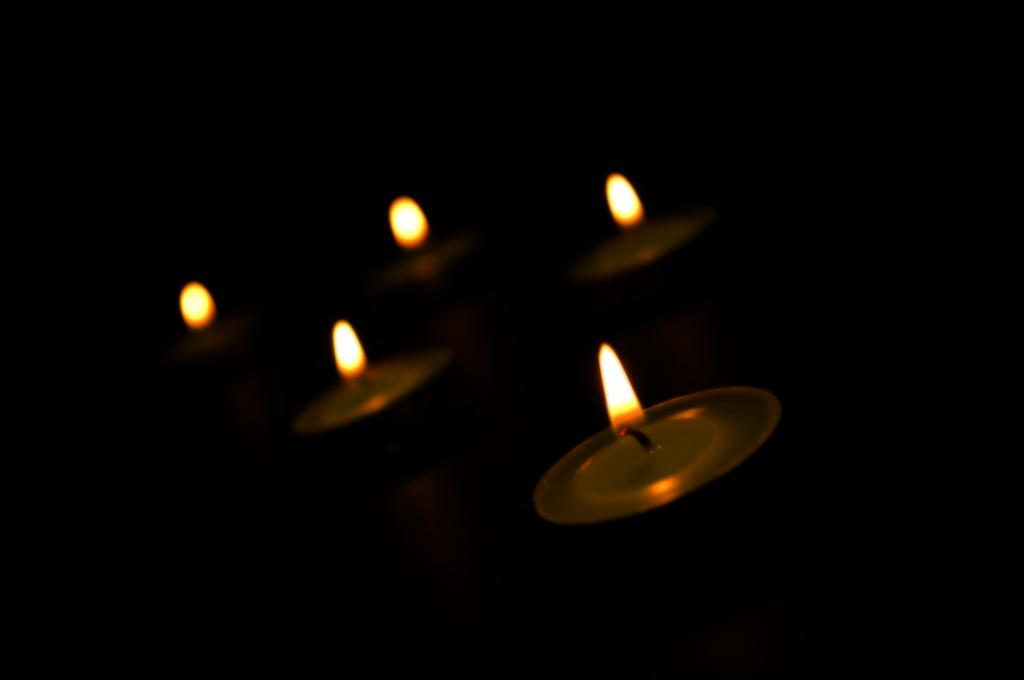What type of objects are in the image? There are small candles in the image. How are the small candles arranged or placed? The small candles are placed in small metal plates. Can you hear the candles laughing in the image? Candles do not have the ability to laugh, so it is not possible to hear them laughing in the image. 